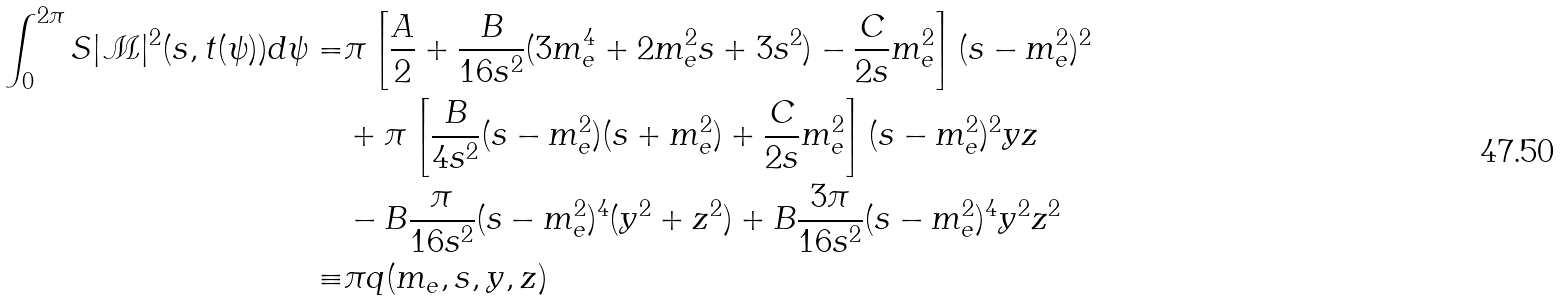Convert formula to latex. <formula><loc_0><loc_0><loc_500><loc_500>\int _ { 0 } ^ { 2 \pi } S | \mathcal { M } | ^ { 2 } ( s , t ( \psi ) ) d \psi = & \pi \left [ \frac { A } { 2 } + \frac { B } { 1 6 s ^ { 2 } } ( 3 m _ { e } ^ { 4 } + 2 m _ { e } ^ { 2 } s + 3 s ^ { 2 } ) - \frac { C } { 2 s } m _ { e } ^ { 2 } \right ] ( s - m _ { e } ^ { 2 } ) ^ { 2 } \\ & + \pi \left [ \frac { B } { 4 s ^ { 2 } } ( s - m _ { e } ^ { 2 } ) ( s + m _ { e } ^ { 2 } ) + \frac { C } { 2 s } m _ { e } ^ { 2 } \right ] ( s - m _ { e } ^ { 2 } ) ^ { 2 } y z \\ & - B \frac { \pi } { 1 6 s ^ { 2 } } ( s - m _ { e } ^ { 2 } ) ^ { 4 } ( y ^ { 2 } + z ^ { 2 } ) + B \frac { 3 \pi } { 1 6 s ^ { 2 } } ( s - m _ { e } ^ { 2 } ) ^ { 4 } y ^ { 2 } z ^ { 2 } \\ \equiv & \pi q ( m _ { e } , s , y , z )</formula> 